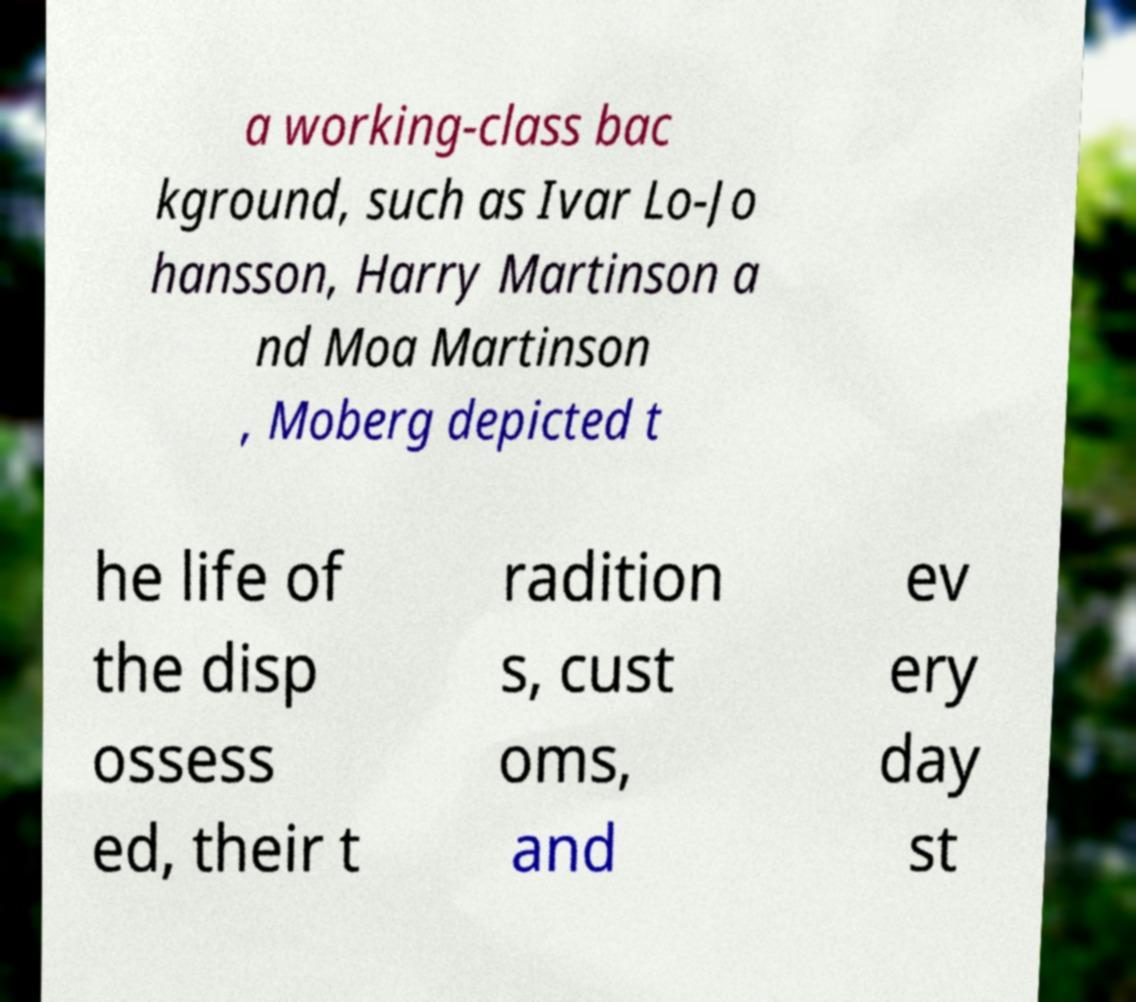Please read and relay the text visible in this image. What does it say? a working-class bac kground, such as Ivar Lo-Jo hansson, Harry Martinson a nd Moa Martinson , Moberg depicted t he life of the disp ossess ed, their t radition s, cust oms, and ev ery day st 